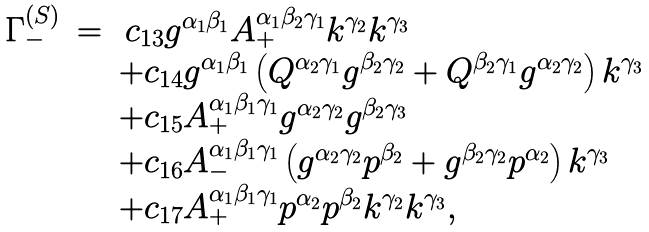<formula> <loc_0><loc_0><loc_500><loc_500>\begin{array} { r c l } \Gamma _ { - } ^ { ( S ) } & = & \, c _ { 1 3 } g ^ { \alpha _ { 1 } \beta _ { 1 } } A _ { + } ^ { \alpha _ { 1 } \beta _ { 2 } \gamma _ { 1 } } k ^ { \gamma _ { 2 } } k ^ { \gamma _ { 3 } } \\ & & + c _ { 1 4 } g ^ { \alpha _ { 1 } \beta _ { 1 } } \left ( Q ^ { \alpha _ { 2 } \gamma _ { 1 } } g ^ { \beta _ { 2 } \gamma _ { 2 } } + Q ^ { \beta _ { 2 } \gamma _ { 1 } } g ^ { \alpha _ { 2 } \gamma _ { 2 } } \right ) k ^ { \gamma _ { 3 } } \\ & & + c _ { 1 5 } A _ { + } ^ { \alpha _ { 1 } \beta _ { 1 } \gamma _ { 1 } } g ^ { \alpha _ { 2 } \gamma _ { 2 } } g ^ { \beta _ { 2 } \gamma _ { 3 } } \\ & & + c _ { 1 6 } A _ { - } ^ { \alpha _ { 1 } \beta _ { 1 } \gamma _ { 1 } } \left ( g ^ { \alpha _ { 2 } \gamma _ { 2 } } p ^ { \beta _ { 2 } } + g ^ { \beta _ { 2 } \gamma _ { 2 } } p ^ { \alpha _ { 2 } } \right ) k ^ { \gamma _ { 3 } } \\ & & + c _ { 1 7 } A _ { + } ^ { \alpha _ { 1 } \beta _ { 1 } \gamma _ { 1 } } p ^ { \alpha _ { 2 } } p ^ { \beta _ { 2 } } k ^ { \gamma _ { 2 } } k ^ { \gamma _ { 3 } } , \end{array}</formula> 